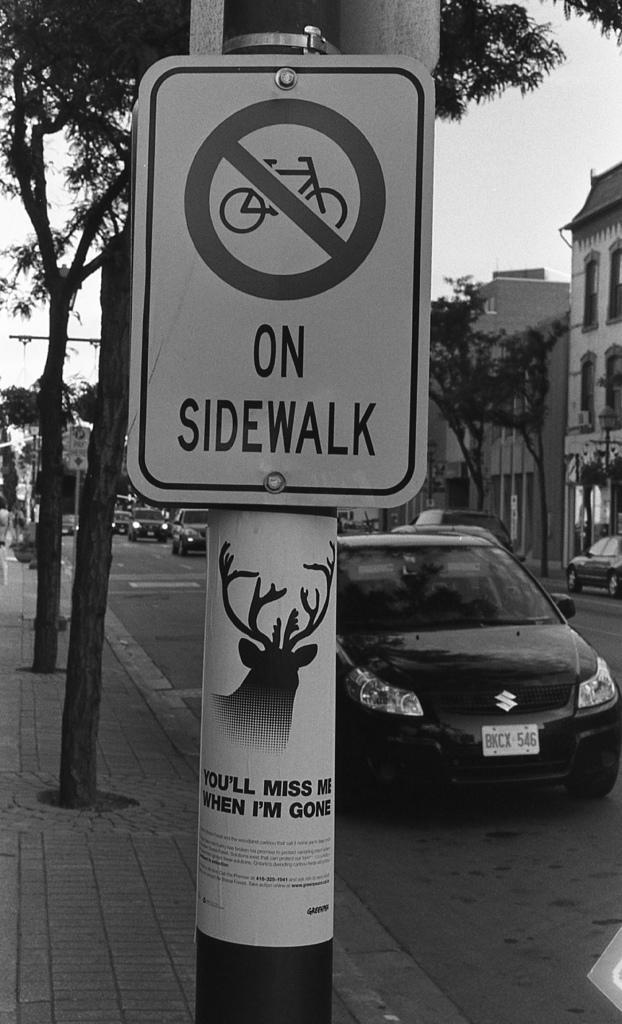In one or two sentences, can you explain what this image depicts? In the center of the image there is a sign board. In the background of the image there are buildings, trees. There is road on which there are vehicles. 